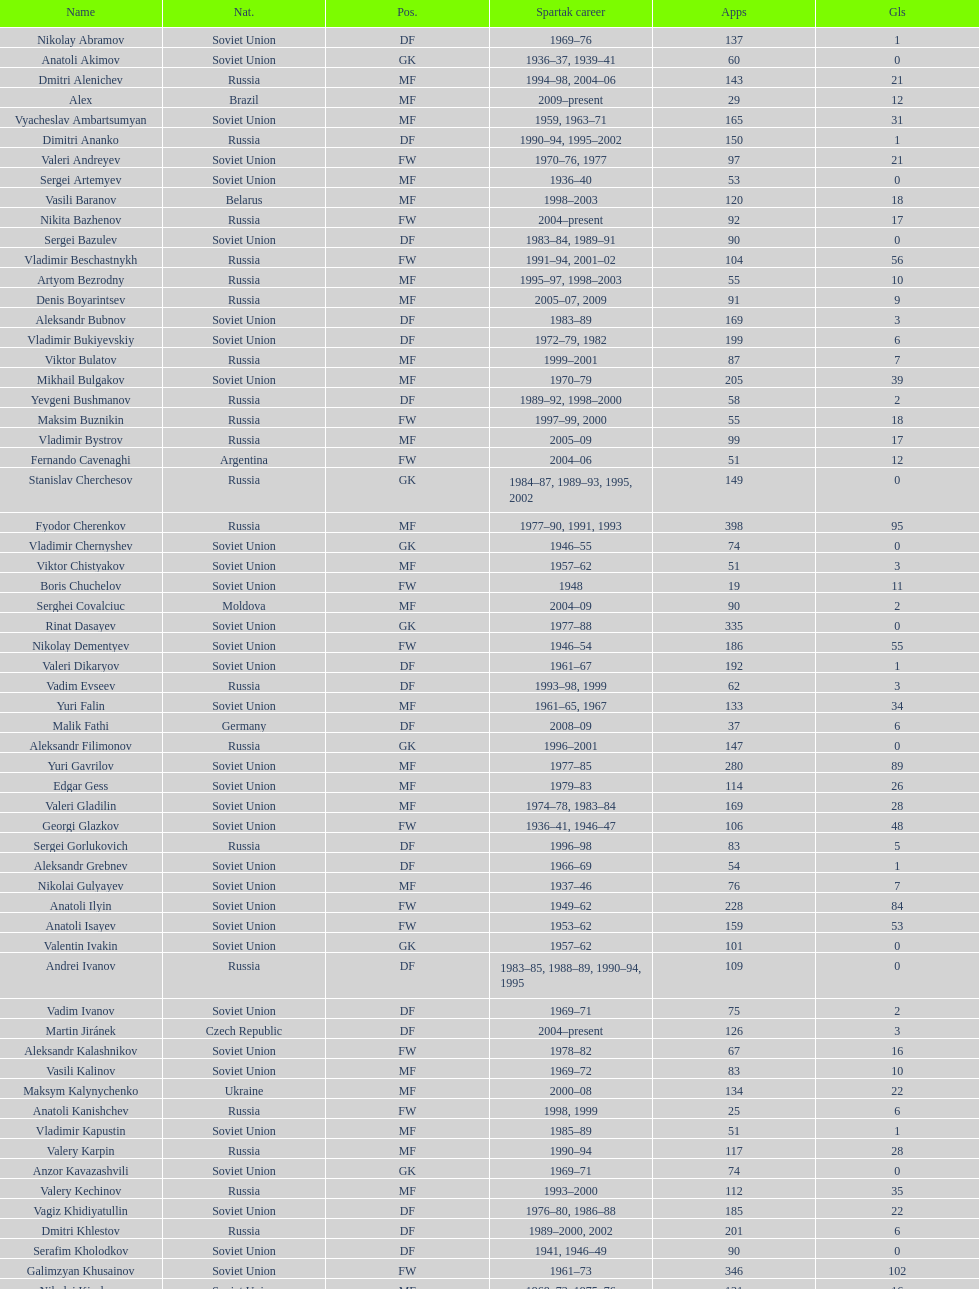Would you be able to parse every entry in this table? {'header': ['Name', 'Nat.', 'Pos.', 'Spartak career', 'Apps', 'Gls'], 'rows': [['Nikolay Abramov', 'Soviet Union', 'DF', '1969–76', '137', '1'], ['Anatoli Akimov', 'Soviet Union', 'GK', '1936–37, 1939–41', '60', '0'], ['Dmitri Alenichev', 'Russia', 'MF', '1994–98, 2004–06', '143', '21'], ['Alex', 'Brazil', 'MF', '2009–present', '29', '12'], ['Vyacheslav Ambartsumyan', 'Soviet Union', 'MF', '1959, 1963–71', '165', '31'], ['Dimitri Ananko', 'Russia', 'DF', '1990–94, 1995–2002', '150', '1'], ['Valeri Andreyev', 'Soviet Union', 'FW', '1970–76, 1977', '97', '21'], ['Sergei Artemyev', 'Soviet Union', 'MF', '1936–40', '53', '0'], ['Vasili Baranov', 'Belarus', 'MF', '1998–2003', '120', '18'], ['Nikita Bazhenov', 'Russia', 'FW', '2004–present', '92', '17'], ['Sergei Bazulev', 'Soviet Union', 'DF', '1983–84, 1989–91', '90', '0'], ['Vladimir Beschastnykh', 'Russia', 'FW', '1991–94, 2001–02', '104', '56'], ['Artyom Bezrodny', 'Russia', 'MF', '1995–97, 1998–2003', '55', '10'], ['Denis Boyarintsev', 'Russia', 'MF', '2005–07, 2009', '91', '9'], ['Aleksandr Bubnov', 'Soviet Union', 'DF', '1983–89', '169', '3'], ['Vladimir Bukiyevskiy', 'Soviet Union', 'DF', '1972–79, 1982', '199', '6'], ['Viktor Bulatov', 'Russia', 'MF', '1999–2001', '87', '7'], ['Mikhail Bulgakov', 'Soviet Union', 'MF', '1970–79', '205', '39'], ['Yevgeni Bushmanov', 'Russia', 'DF', '1989–92, 1998–2000', '58', '2'], ['Maksim Buznikin', 'Russia', 'FW', '1997–99, 2000', '55', '18'], ['Vladimir Bystrov', 'Russia', 'MF', '2005–09', '99', '17'], ['Fernando Cavenaghi', 'Argentina', 'FW', '2004–06', '51', '12'], ['Stanislav Cherchesov', 'Russia', 'GK', '1984–87, 1989–93, 1995, 2002', '149', '0'], ['Fyodor Cherenkov', 'Russia', 'MF', '1977–90, 1991, 1993', '398', '95'], ['Vladimir Chernyshev', 'Soviet Union', 'GK', '1946–55', '74', '0'], ['Viktor Chistyakov', 'Soviet Union', 'MF', '1957–62', '51', '3'], ['Boris Chuchelov', 'Soviet Union', 'FW', '1948', '19', '11'], ['Serghei Covalciuc', 'Moldova', 'MF', '2004–09', '90', '2'], ['Rinat Dasayev', 'Soviet Union', 'GK', '1977–88', '335', '0'], ['Nikolay Dementyev', 'Soviet Union', 'FW', '1946–54', '186', '55'], ['Valeri Dikaryov', 'Soviet Union', 'DF', '1961–67', '192', '1'], ['Vadim Evseev', 'Russia', 'DF', '1993–98, 1999', '62', '3'], ['Yuri Falin', 'Soviet Union', 'MF', '1961–65, 1967', '133', '34'], ['Malik Fathi', 'Germany', 'DF', '2008–09', '37', '6'], ['Aleksandr Filimonov', 'Russia', 'GK', '1996–2001', '147', '0'], ['Yuri Gavrilov', 'Soviet Union', 'MF', '1977–85', '280', '89'], ['Edgar Gess', 'Soviet Union', 'MF', '1979–83', '114', '26'], ['Valeri Gladilin', 'Soviet Union', 'MF', '1974–78, 1983–84', '169', '28'], ['Georgi Glazkov', 'Soviet Union', 'FW', '1936–41, 1946–47', '106', '48'], ['Sergei Gorlukovich', 'Russia', 'DF', '1996–98', '83', '5'], ['Aleksandr Grebnev', 'Soviet Union', 'DF', '1966–69', '54', '1'], ['Nikolai Gulyayev', 'Soviet Union', 'MF', '1937–46', '76', '7'], ['Anatoli Ilyin', 'Soviet Union', 'FW', '1949–62', '228', '84'], ['Anatoli Isayev', 'Soviet Union', 'FW', '1953–62', '159', '53'], ['Valentin Ivakin', 'Soviet Union', 'GK', '1957–62', '101', '0'], ['Andrei Ivanov', 'Russia', 'DF', '1983–85, 1988–89, 1990–94, 1995', '109', '0'], ['Vadim Ivanov', 'Soviet Union', 'DF', '1969–71', '75', '2'], ['Martin Jiránek', 'Czech Republic', 'DF', '2004–present', '126', '3'], ['Aleksandr Kalashnikov', 'Soviet Union', 'FW', '1978–82', '67', '16'], ['Vasili Kalinov', 'Soviet Union', 'MF', '1969–72', '83', '10'], ['Maksym Kalynychenko', 'Ukraine', 'MF', '2000–08', '134', '22'], ['Anatoli Kanishchev', 'Russia', 'FW', '1998, 1999', '25', '6'], ['Vladimir Kapustin', 'Soviet Union', 'MF', '1985–89', '51', '1'], ['Valery Karpin', 'Russia', 'MF', '1990–94', '117', '28'], ['Anzor Kavazashvili', 'Soviet Union', 'GK', '1969–71', '74', '0'], ['Valery Kechinov', 'Russia', 'MF', '1993–2000', '112', '35'], ['Vagiz Khidiyatullin', 'Soviet Union', 'DF', '1976–80, 1986–88', '185', '22'], ['Dmitri Khlestov', 'Russia', 'DF', '1989–2000, 2002', '201', '6'], ['Serafim Kholodkov', 'Soviet Union', 'DF', '1941, 1946–49', '90', '0'], ['Galimzyan Khusainov', 'Soviet Union', 'FW', '1961–73', '346', '102'], ['Nikolai Kiselyov', 'Soviet Union', 'MF', '1968–73, 1975–76', '131', '16'], ['Aleksandr Kokorev', 'Soviet Union', 'MF', '1972–80', '90', '4'], ['Ivan Konov', 'Soviet Union', 'FW', '1945–48', '85', '31'], ['Viktor Konovalov', 'Soviet Union', 'MF', '1960–61', '24', '5'], ['Alexey Korneyev', 'Soviet Union', 'DF', '1957–67', '177', '0'], ['Pavel Kornilov', 'Soviet Union', 'FW', '1938–41', '65', '38'], ['Radoslav Kováč', 'Czech Republic', 'MF', '2005–08', '101', '9'], ['Yuri Kovtun', 'Russia', 'DF', '1999–2005', '122', '7'], ['Wojciech Kowalewski', 'Poland', 'GK', '2003–07', '94', '0'], ['Anatoly Krutikov', 'Soviet Union', 'DF', '1959–69', '269', '9'], ['Dmitri Kudryashov', 'Russia', 'MF', '2002', '22', '5'], ['Vasili Kulkov', 'Russia', 'DF', '1986, 1989–91, 1995, 1997', '93', '4'], ['Boris Kuznetsov', 'Soviet Union', 'DF', '1985–88, 1989–90', '90', '0'], ['Yevgeni Kuznetsov', 'Soviet Union', 'MF', '1982–89', '209', '23'], ['Igor Lediakhov', 'Russia', 'MF', '1992–94', '65', '21'], ['Aleksei Leontyev', 'Soviet Union', 'GK', '1940–49', '109', '0'], ['Boris Lobutev', 'Soviet Union', 'FW', '1957–60', '15', '7'], ['Gennady Logofet', 'Soviet Union', 'DF', '1960–75', '349', '27'], ['Evgeny Lovchev', 'Soviet Union', 'MF', '1969–78', '249', '30'], ['Konstantin Malinin', 'Soviet Union', 'DF', '1939–50', '140', '7'], ['Ramiz Mamedov', 'Russia', 'DF', '1991–98', '125', '6'], ['Valeri Masalitin', 'Russia', 'FW', '1994–95', '7', '5'], ['Vladimir Maslachenko', 'Soviet Union', 'GK', '1962–68', '196', '0'], ['Anatoli Maslyonkin', 'Soviet Union', 'DF', '1954–63', '216', '8'], ['Aleksei Melyoshin', 'Russia', 'MF', '1995–2000', '68', '5'], ['Aleksandr Minayev', 'Soviet Union', 'MF', '1972–75', '92', '10'], ['Alexander Mirzoyan', 'Soviet Union', 'DF', '1979–83', '80', '9'], ['Vitali Mirzoyev', 'Soviet Union', 'FW', '1971–74', '58', '4'], ['Viktor Mishin', 'Soviet Union', 'FW', '1956–61', '43', '8'], ['Igor Mitreski', 'Macedonia', 'DF', '2001–04', '85', '0'], ['Gennady Morozov', 'Soviet Union', 'DF', '1980–86, 1989–90', '196', '3'], ['Aleksandr Mostovoi', 'Soviet Union', 'MF', '1986–91', '106', '34'], ['Mozart', 'Brazil', 'MF', '2005–08', '68', '7'], ['Ivan Mozer', 'Soviet Union', 'MF', '1956–61', '96', '30'], ['Mukhsin Mukhamadiev', 'Russia', 'MF', '1994–95', '30', '13'], ['Igor Netto', 'Soviet Union', 'MF', '1949–66', '368', '36'], ['Yuriy Nikiforov', 'Russia', 'DF', '1993–96', '85', '16'], ['Vladimir Nikonov', 'Soviet Union', 'MF', '1979–80, 1982', '25', '5'], ['Sergei Novikov', 'Soviet Union', 'MF', '1978–80, 1985–89', '70', '12'], ['Mikhail Ogonkov', 'Soviet Union', 'DF', '1953–58, 1961', '78', '0'], ['Sergei Olshansky', 'Soviet Union', 'DF', '1969–75', '138', '7'], ['Viktor Onopko', 'Russia', 'DF', '1992–95', '108', '23'], ['Nikolai Osyanin', 'Soviet Union', 'DF', '1966–71, 1974–76', '248', '50'], ['Viktor Papayev', 'Soviet Union', 'MF', '1968–73, 1975–76', '174', '10'], ['Aleksei Paramonov', 'Soviet Union', 'MF', '1947–59', '264', '61'], ['Dmytro Parfenov', 'Ukraine', 'DF', '1998–2005', '125', '15'], ['Nikolai Parshin', 'Soviet Union', 'FW', '1949–58', '106', '36'], ['Viktor Pasulko', 'Soviet Union', 'MF', '1987–89', '75', '16'], ['Aleksandr Pavlenko', 'Russia', 'MF', '2001–07, 2008–09', '110', '11'], ['Vadim Pavlenko', 'Soviet Union', 'FW', '1977–78', '47', '16'], ['Roman Pavlyuchenko', 'Russia', 'FW', '2003–08', '141', '69'], ['Hennadiy Perepadenko', 'Ukraine', 'MF', '1990–91, 1992', '51', '6'], ['Boris Petrov', 'Soviet Union', 'FW', '1962', '18', '5'], ['Vladimir Petrov', 'Soviet Union', 'DF', '1959–71', '174', '5'], ['Andrei Piatnitski', 'Russia', 'MF', '1992–97', '100', '17'], ['Nikolai Pisarev', 'Russia', 'FW', '1992–95, 1998, 2000–01', '115', '32'], ['Aleksandr Piskaryov', 'Soviet Union', 'FW', '1971–75', '117', '33'], ['Mihajlo Pjanović', 'Serbia', 'FW', '2003–06', '48', '11'], ['Stipe Pletikosa', 'Croatia', 'GK', '2007–present', '63', '0'], ['Dmitri Popov', 'Russia', 'DF', '1989–93', '78', '7'], ['Boris Pozdnyakov', 'Soviet Union', 'DF', '1978–84, 1989–91', '145', '3'], ['Vladimir Pribylov', 'Soviet Union', 'FW', '1964–69', '35', '6'], ['Aleksandr Prokhorov', 'Soviet Union', 'GK', '1972–75, 1976–78', '143', '0'], ['Andrei Protasov', 'Soviet Union', 'FW', '1939–41', '32', '10'], ['Dmitri Radchenko', 'Russia', 'FW', '1991–93', '61', '27'], ['Vladimir Redin', 'Soviet Union', 'MF', '1970–74, 1976', '90', '12'], ['Valeri Reyngold', 'Soviet Union', 'FW', '1960–67', '176', '32'], ['Luis Robson', 'Brazil', 'FW', '1997–2001', '102', '32'], ['Sergey Rodionov', 'Russia', 'FW', '1979–90, 1993–95', '303', '124'], ['Clemente Rodríguez', 'Argentina', 'DF', '2004–06, 2008–09', '71', '3'], ['Oleg Romantsev', 'Soviet Union', 'DF', '1976–83', '180', '6'], ['Miroslav Romaschenko', 'Belarus', 'MF', '1997–98', '42', '7'], ['Sergei Rozhkov', 'Soviet Union', 'MF', '1961–65, 1967–69, 1974', '143', '8'], ['Andrei Rudakov', 'Soviet Union', 'FW', '1985–87', '49', '17'], ['Leonid Rumyantsev', 'Soviet Union', 'FW', '1936–40', '26', '8'], ['Mikhail Rusyayev', 'Russia', 'FW', '1981–87, 1992', '47', '9'], ['Konstantin Ryazantsev', 'Soviet Union', 'MF', '1941, 1944–51', '114', '5'], ['Aleksandr Rystsov', 'Soviet Union', 'FW', '1947–54', '100', '16'], ['Sergei Salnikov', 'Soviet Union', 'FW', '1946–49, 1955–60', '201', '64'], ['Aleksandr Samedov', 'Russia', 'MF', '2001–05', '47', '6'], ['Viktor Samokhin', 'Soviet Union', 'MF', '1974–81', '188', '3'], ['Yuri Sedov', 'Soviet Union', 'DF', '1948–55, 1957–59', '176', '2'], ['Anatoli Seglin', 'Soviet Union', 'DF', '1945–52', '83', '0'], ['Viktor Semyonov', 'Soviet Union', 'FW', '1937–47', '104', '49'], ['Yuri Sevidov', 'Soviet Union', 'FW', '1960–65', '146', '54'], ['Igor Shalimov', 'Russia', 'MF', '1986–91', '95', '20'], ['Sergey Shavlo', 'Soviet Union', 'MF', '1977–82, 1984–85', '256', '48'], ['Aleksandr Shirko', 'Russia', 'FW', '1993–2001', '128', '40'], ['Roman Shishkin', 'Russia', 'DF', '2003–08', '54', '1'], ['Valeri Shmarov', 'Russia', 'FW', '1987–91, 1995–96', '143', '54'], ['Sergei Shvetsov', 'Soviet Union', 'DF', '1981–84', '68', '14'], ['Yevgeni Sidorov', 'Soviet Union', 'MF', '1974–81, 1984–85', '191', '18'], ['Dzhemal Silagadze', 'Soviet Union', 'FW', '1968–71, 1973', '91', '12'], ['Nikita Simonyan', 'Soviet Union', 'FW', '1949–59', '215', '135'], ['Boris Smyslov', 'Soviet Union', 'FW', '1945–48', '45', '6'], ['Florin Şoavă', 'Romania', 'DF', '2004–05, 2007–08', '52', '1'], ['Vladimir Sochnov', 'Soviet Union', 'DF', '1981–85, 1989', '148', '9'], ['Aleksei Sokolov', 'Soviet Union', 'FW', '1938–41, 1942, 1944–47', '114', '49'], ['Vasili Sokolov', 'Soviet Union', 'DF', '1938–41, 1942–51', '262', '2'], ['Viktor Sokolov', 'Soviet Union', 'DF', '1936–41, 1942–46', '121', '0'], ['Anatoli Soldatov', 'Soviet Union', 'DF', '1958–65', '113', '1'], ['Aleksandr Sorokin', 'Soviet Union', 'MF', '1977–80', '107', '9'], ['Andrei Starostin', 'Soviet Union', 'MF', '1936–40', '95', '4'], ['Vladimir Stepanov', 'Soviet Union', 'FW', '1936–41, 1942', '101', '33'], ['Andrejs Štolcers', 'Latvia', 'MF', '2000', '11', '5'], ['Martin Stranzl', 'Austria', 'DF', '2006–present', '80', '3'], ['Yuri Susloparov', 'Soviet Union', 'DF', '1986–90', '80', '1'], ['Yuri Syomin', 'Soviet Union', 'MF', '1965–67', '43', '6'], ['Dmitri Sychev', 'Russia', 'FW', '2002', '18', '9'], ['Boris Tatushin', 'Soviet Union', 'FW', '1953–58, 1961', '116', '38'], ['Viktor Terentyev', 'Soviet Union', 'FW', '1948–53', '103', '34'], ['Andrey Tikhonov', 'Russia', 'MF', '1992–2000', '191', '68'], ['Oleg Timakov', 'Soviet Union', 'MF', '1945–54', '182', '19'], ['Nikolai Tishchenko', 'Soviet Union', 'DF', '1951–58', '106', '0'], ['Yegor Titov', 'Russia', 'MF', '1992–2008', '324', '86'], ['Eduard Tsykhmeystruk', 'Ukraine', 'FW', '2001–02', '35', '5'], ['Ilya Tsymbalar', 'Russia', 'MF', '1993–99', '146', '42'], ['Grigori Tuchkov', 'Soviet Union', 'DF', '1937–41, 1942, 1944', '74', '2'], ['Vladas Tučkus', 'Soviet Union', 'GK', '1954–57', '60', '0'], ['Ivan Varlamov', 'Soviet Union', 'DF', '1964–68', '75', '0'], ['Welliton', 'Brazil', 'FW', '2007–present', '77', '51'], ['Vladimir Yanishevskiy', 'Soviet Union', 'FW', '1965–66', '46', '7'], ['Vladimir Yankin', 'Soviet Union', 'MF', '1966–70', '93', '19'], ['Georgi Yartsev', 'Soviet Union', 'FW', '1977–80', '116', '55'], ['Valentin Yemyshev', 'Soviet Union', 'FW', '1948–53', '23', '9'], ['Aleksei Yeryomenko', 'Soviet Union', 'MF', '1986–87', '26', '5'], ['Viktor Yevlentyev', 'Soviet Union', 'MF', '1963–65, 1967–70', '56', '11'], ['Sergei Yuran', 'Russia', 'FW', '1995, 1999', '26', '5'], ['Valeri Zenkov', 'Soviet Union', 'DF', '1971–74', '59', '1']]} Which player has the highest number of goals? Nikita Simonyan. 